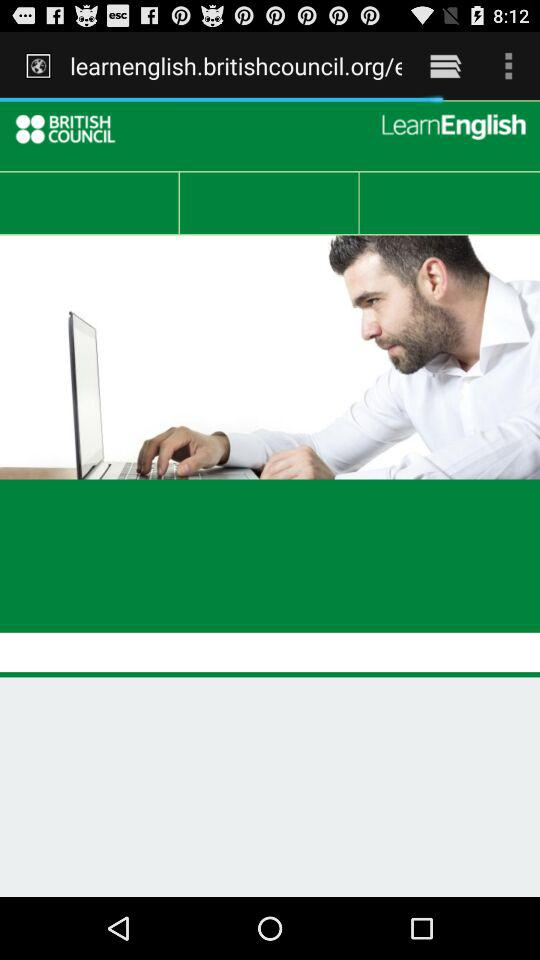Which option is selected?
When the provided information is insufficient, respond with <no answer>. <no answer> 